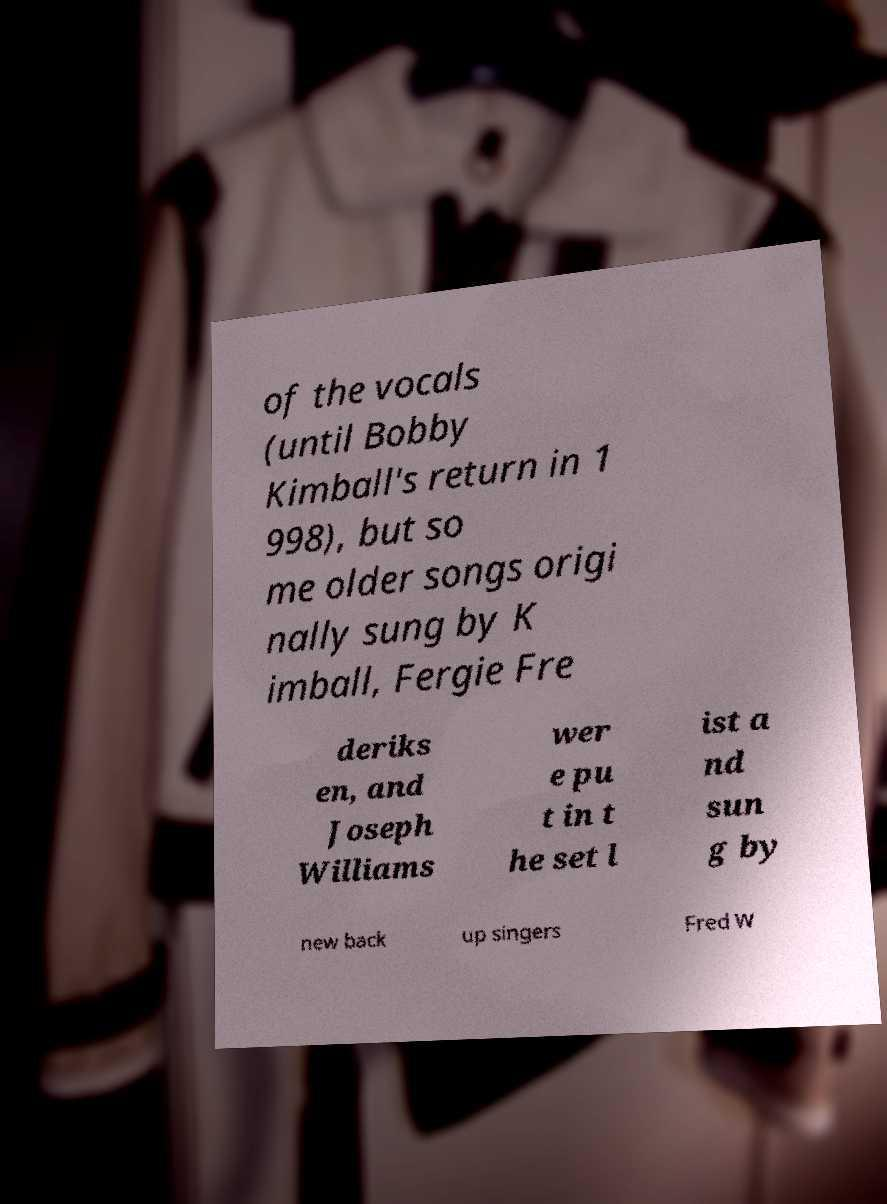For documentation purposes, I need the text within this image transcribed. Could you provide that? of the vocals (until Bobby Kimball's return in 1 998), but so me older songs origi nally sung by K imball, Fergie Fre deriks en, and Joseph Williams wer e pu t in t he set l ist a nd sun g by new back up singers Fred W 